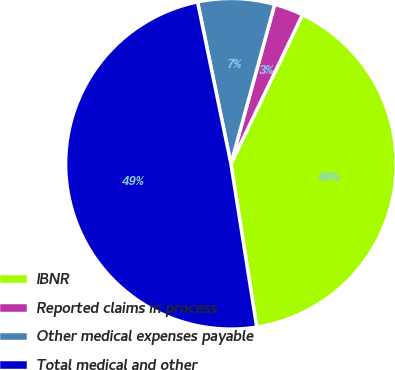Convert chart to OTSL. <chart><loc_0><loc_0><loc_500><loc_500><pie_chart><fcel>IBNR<fcel>Reported claims in process<fcel>Other medical expenses payable<fcel>Total medical and other<nl><fcel>40.39%<fcel>2.86%<fcel>7.5%<fcel>49.26%<nl></chart> 